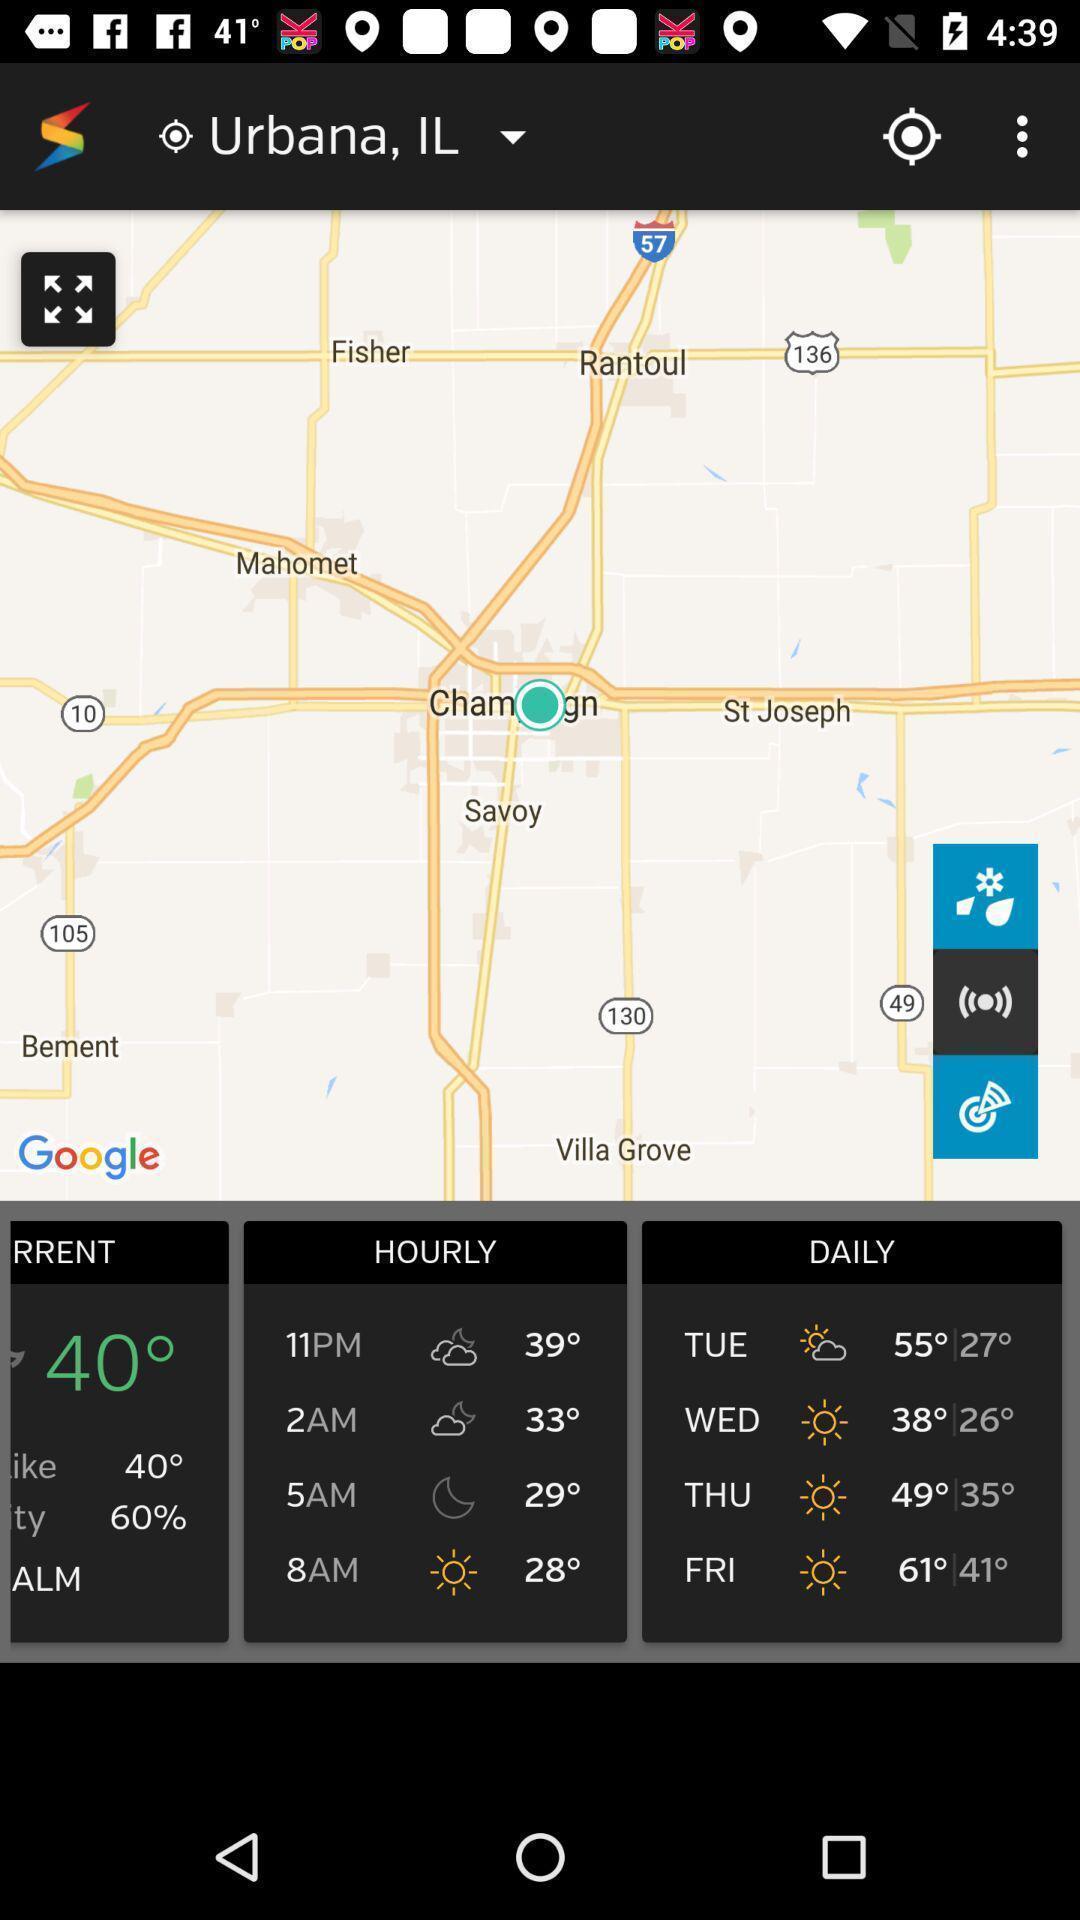Summarize the main components in this picture. Screen shows map view in a weather app. 